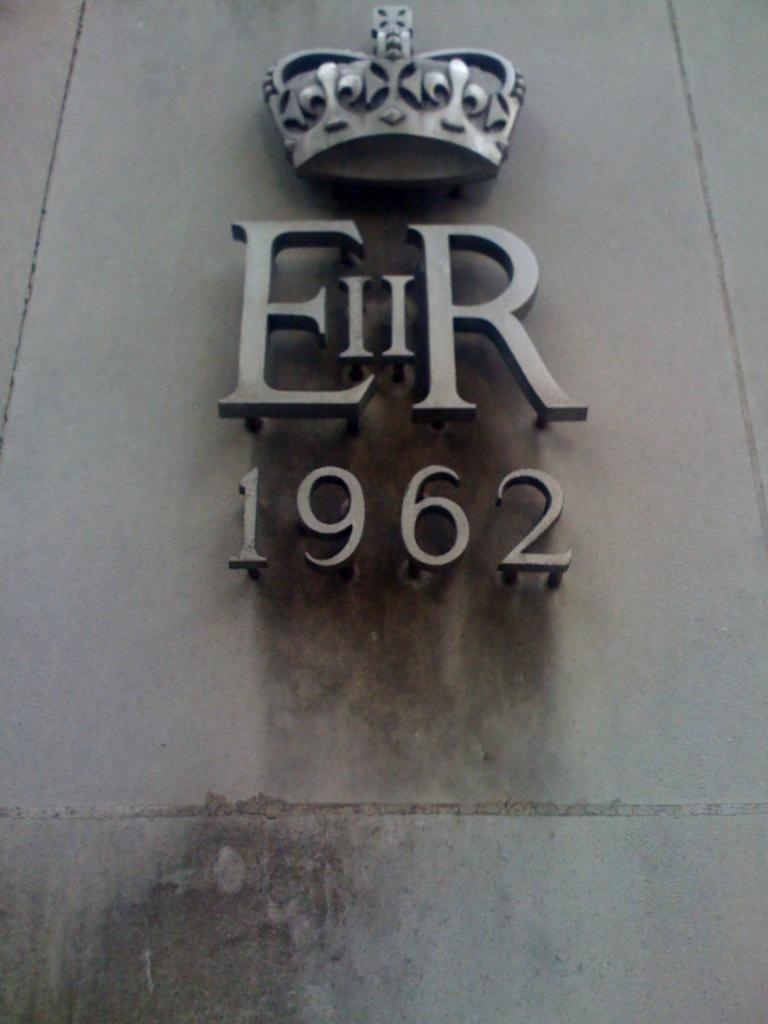What is present on the wall in the image? There are emblems fitted to the wall in the image. What is located above the emblems on the wall? There is a crown above the emblems in the image. Can you describe the wall in the image? The wall has emblems and a crown on it. What type of apparel is the wall wearing in the image? The wall is not wearing any apparel, as it is an inanimate object. Is there any indication of a battle taking place in the image? There is no indication of a battle in the image; it only features a wall with emblems and a crown. 